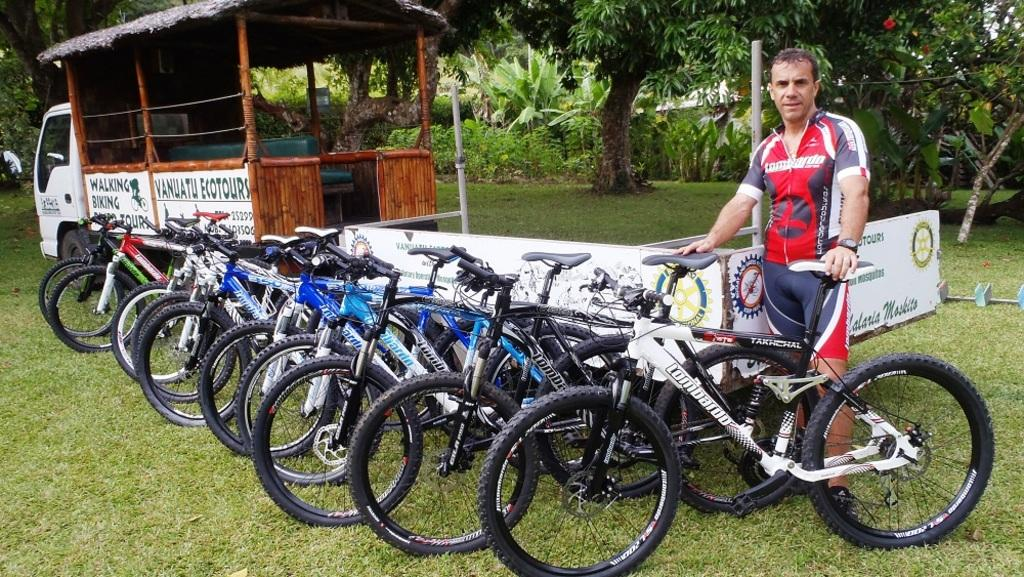What is located on the right side of the image? There is a man standing on the right side of the image. What can be seen parked in the image? There are cycles parked in the image. What is on the left side of the image? There is a vehicle on the left side of the image. What is visible in the background of the image? Trees are visible in the background of the image. How many yaks are present in the image? There are no yaks present in the image. What type of cast can be seen on the man's arm in the image? There is no cast visible on the man's arm in the image. 